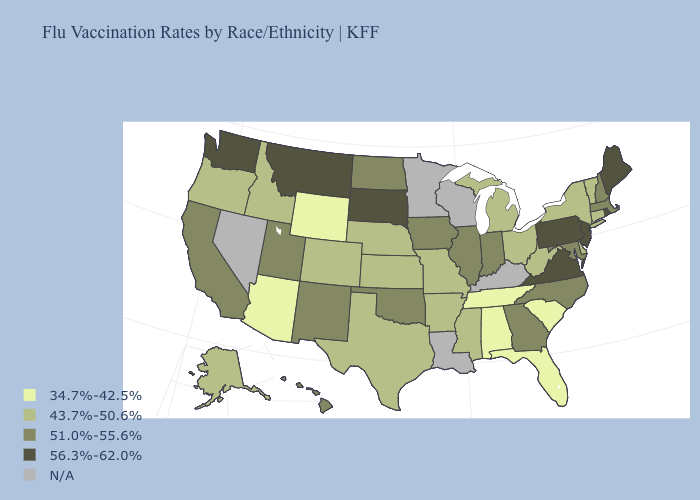What is the highest value in states that border Ohio?
Answer briefly. 56.3%-62.0%. Does Washington have the highest value in the USA?
Write a very short answer. Yes. What is the lowest value in the Northeast?
Give a very brief answer. 43.7%-50.6%. Name the states that have a value in the range 34.7%-42.5%?
Be succinct. Alabama, Arizona, Florida, South Carolina, Tennessee, Wyoming. What is the lowest value in the USA?
Quick response, please. 34.7%-42.5%. What is the value of Vermont?
Keep it brief. 43.7%-50.6%. Name the states that have a value in the range 43.7%-50.6%?
Answer briefly. Alaska, Arkansas, Colorado, Connecticut, Delaware, Idaho, Kansas, Michigan, Mississippi, Missouri, Nebraska, New York, Ohio, Oregon, Texas, Vermont, West Virginia. What is the highest value in the South ?
Keep it brief. 56.3%-62.0%. Does Arizona have the lowest value in the USA?
Write a very short answer. Yes. How many symbols are there in the legend?
Keep it brief. 5. Among the states that border Louisiana , which have the highest value?
Answer briefly. Arkansas, Mississippi, Texas. Does Virginia have the highest value in the South?
Quick response, please. Yes. Name the states that have a value in the range N/A?
Be succinct. Kentucky, Louisiana, Minnesota, Nevada, Wisconsin. 